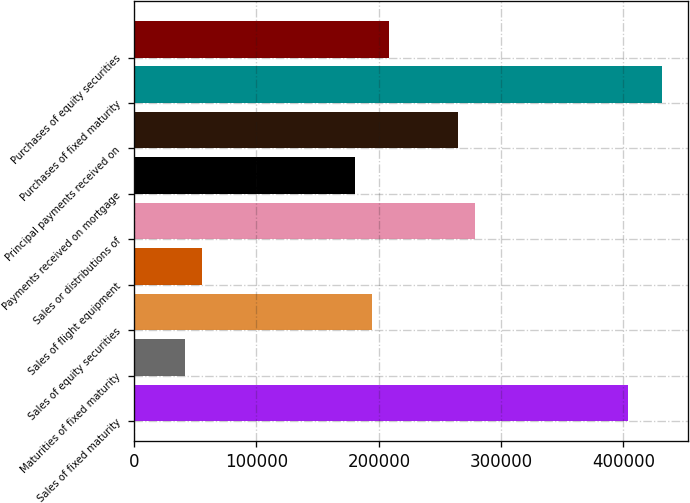Convert chart to OTSL. <chart><loc_0><loc_0><loc_500><loc_500><bar_chart><fcel>Sales of fixed maturity<fcel>Maturities of fixed maturity<fcel>Sales of equity securities<fcel>Sales of flight equipment<fcel>Sales or distributions of<fcel>Payments received on mortgage<fcel>Principal payments received on<fcel>Purchases of fixed maturity<fcel>Purchases of equity securities<nl><fcel>403409<fcel>41837.8<fcel>194810<fcel>55744.4<fcel>278250<fcel>180904<fcel>264343<fcel>431223<fcel>208717<nl></chart> 